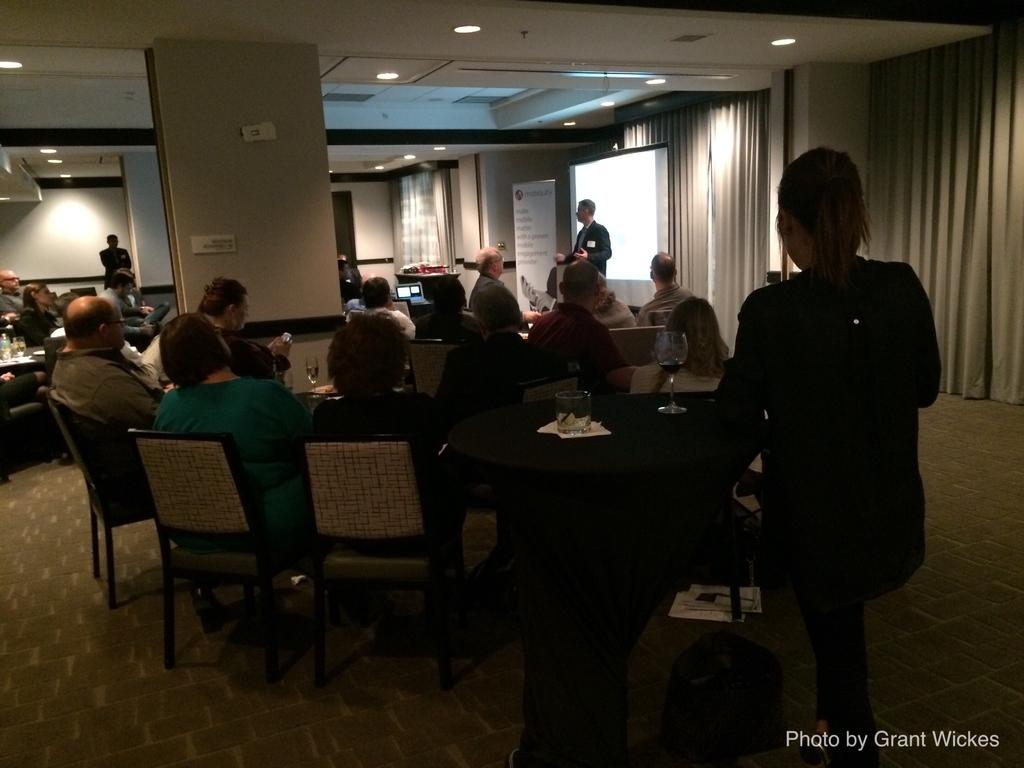What are the people in the image doing? The people in the image are sitting on chairs and listening to the person standing in front of the screen. What is the person standing in front of the screen doing? The person standing in front of the screen is likely presenting or speaking to the audience. What can be seen on the wall in the room? There are lights on the wall in the room. What type of window treatment is present in the room? There are curtains in the room. What color is the fire alarm in the image? There is no fire alarm present in the image. What type of color can be seen on the person standing in front of the screen? The provided facts do not mention any specific colors related to the person standing in front of the screen. 